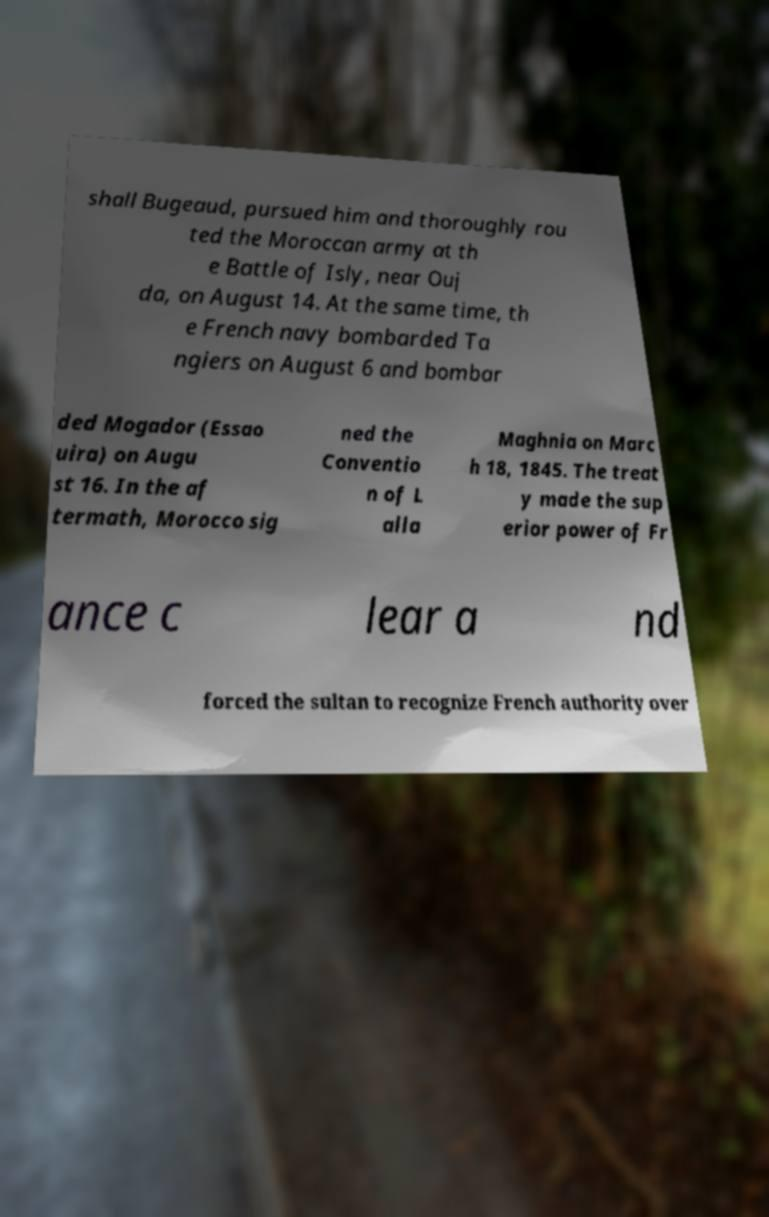What messages or text are displayed in this image? I need them in a readable, typed format. shall Bugeaud, pursued him and thoroughly rou ted the Moroccan army at th e Battle of Isly, near Ouj da, on August 14. At the same time, th e French navy bombarded Ta ngiers on August 6 and bombar ded Mogador (Essao uira) on Augu st 16. In the af termath, Morocco sig ned the Conventio n of L alla Maghnia on Marc h 18, 1845. The treat y made the sup erior power of Fr ance c lear a nd forced the sultan to recognize French authority over 